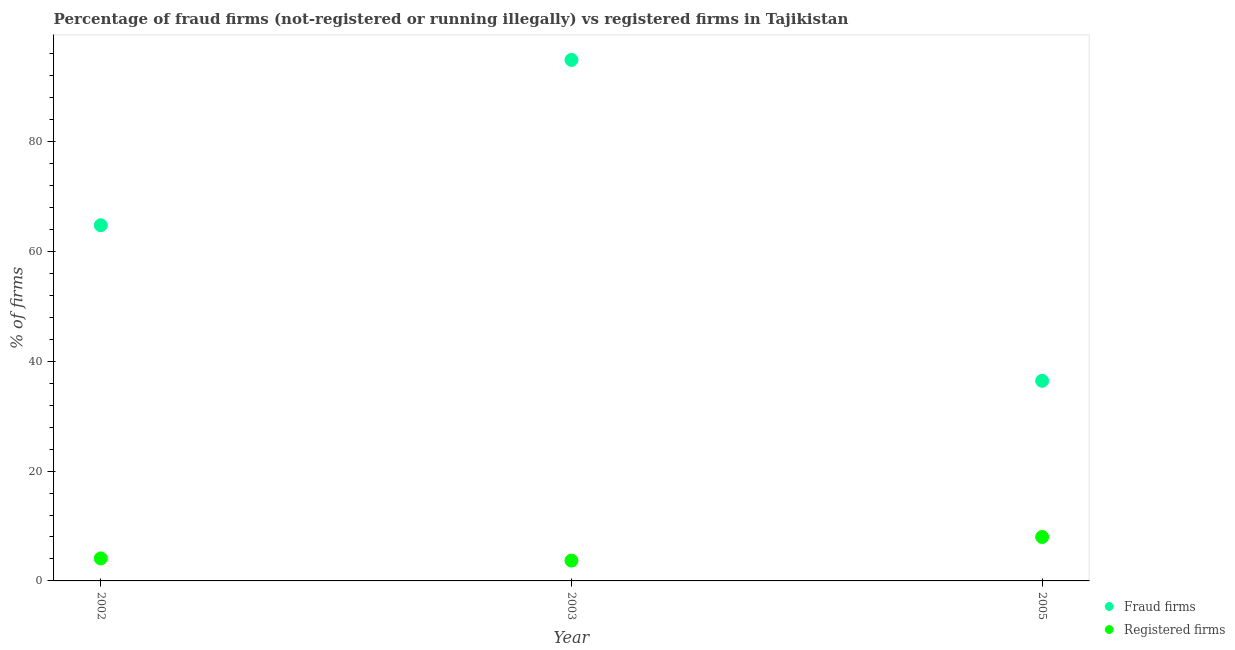How many different coloured dotlines are there?
Your response must be concise. 2. What is the percentage of fraud firms in 2002?
Make the answer very short. 64.75. Across all years, what is the maximum percentage of registered firms?
Make the answer very short. 8. Across all years, what is the minimum percentage of fraud firms?
Provide a short and direct response. 36.43. In which year was the percentage of fraud firms maximum?
Provide a short and direct response. 2003. In which year was the percentage of registered firms minimum?
Offer a very short reply. 2003. What is the total percentage of fraud firms in the graph?
Keep it short and to the point. 196.03. What is the difference between the percentage of registered firms in 2003 and that in 2005?
Ensure brevity in your answer.  -4.3. What is the difference between the percentage of fraud firms in 2003 and the percentage of registered firms in 2002?
Give a very brief answer. 90.75. What is the average percentage of registered firms per year?
Give a very brief answer. 5.27. In the year 2002, what is the difference between the percentage of fraud firms and percentage of registered firms?
Keep it short and to the point. 60.65. What is the ratio of the percentage of fraud firms in 2002 to that in 2003?
Ensure brevity in your answer.  0.68. What is the difference between the highest and the second highest percentage of registered firms?
Keep it short and to the point. 3.9. What is the difference between the highest and the lowest percentage of fraud firms?
Keep it short and to the point. 58.42. In how many years, is the percentage of registered firms greater than the average percentage of registered firms taken over all years?
Give a very brief answer. 1. Is the sum of the percentage of fraud firms in 2002 and 2005 greater than the maximum percentage of registered firms across all years?
Keep it short and to the point. Yes. Is the percentage of fraud firms strictly less than the percentage of registered firms over the years?
Offer a terse response. No. What is the difference between two consecutive major ticks on the Y-axis?
Give a very brief answer. 20. Does the graph contain any zero values?
Your response must be concise. No. Where does the legend appear in the graph?
Provide a succinct answer. Bottom right. How many legend labels are there?
Make the answer very short. 2. What is the title of the graph?
Make the answer very short. Percentage of fraud firms (not-registered or running illegally) vs registered firms in Tajikistan. Does "Rural" appear as one of the legend labels in the graph?
Ensure brevity in your answer.  No. What is the label or title of the X-axis?
Offer a terse response. Year. What is the label or title of the Y-axis?
Make the answer very short. % of firms. What is the % of firms of Fraud firms in 2002?
Offer a terse response. 64.75. What is the % of firms in Fraud firms in 2003?
Ensure brevity in your answer.  94.85. What is the % of firms in Fraud firms in 2005?
Provide a short and direct response. 36.43. What is the % of firms of Registered firms in 2005?
Keep it short and to the point. 8. Across all years, what is the maximum % of firms of Fraud firms?
Keep it short and to the point. 94.85. Across all years, what is the maximum % of firms of Registered firms?
Offer a terse response. 8. Across all years, what is the minimum % of firms of Fraud firms?
Ensure brevity in your answer.  36.43. What is the total % of firms in Fraud firms in the graph?
Your answer should be very brief. 196.03. What is the total % of firms in Registered firms in the graph?
Offer a very short reply. 15.8. What is the difference between the % of firms of Fraud firms in 2002 and that in 2003?
Your response must be concise. -30.1. What is the difference between the % of firms of Fraud firms in 2002 and that in 2005?
Your answer should be compact. 28.32. What is the difference between the % of firms of Registered firms in 2002 and that in 2005?
Keep it short and to the point. -3.9. What is the difference between the % of firms of Fraud firms in 2003 and that in 2005?
Your response must be concise. 58.42. What is the difference between the % of firms of Fraud firms in 2002 and the % of firms of Registered firms in 2003?
Offer a terse response. 61.05. What is the difference between the % of firms of Fraud firms in 2002 and the % of firms of Registered firms in 2005?
Offer a terse response. 56.75. What is the difference between the % of firms in Fraud firms in 2003 and the % of firms in Registered firms in 2005?
Offer a terse response. 86.85. What is the average % of firms of Fraud firms per year?
Make the answer very short. 65.34. What is the average % of firms in Registered firms per year?
Your answer should be very brief. 5.27. In the year 2002, what is the difference between the % of firms of Fraud firms and % of firms of Registered firms?
Provide a succinct answer. 60.65. In the year 2003, what is the difference between the % of firms of Fraud firms and % of firms of Registered firms?
Your response must be concise. 91.15. In the year 2005, what is the difference between the % of firms of Fraud firms and % of firms of Registered firms?
Offer a very short reply. 28.43. What is the ratio of the % of firms of Fraud firms in 2002 to that in 2003?
Make the answer very short. 0.68. What is the ratio of the % of firms in Registered firms in 2002 to that in 2003?
Your response must be concise. 1.11. What is the ratio of the % of firms of Fraud firms in 2002 to that in 2005?
Give a very brief answer. 1.78. What is the ratio of the % of firms in Registered firms in 2002 to that in 2005?
Your response must be concise. 0.51. What is the ratio of the % of firms of Fraud firms in 2003 to that in 2005?
Give a very brief answer. 2.6. What is the ratio of the % of firms of Registered firms in 2003 to that in 2005?
Your response must be concise. 0.46. What is the difference between the highest and the second highest % of firms in Fraud firms?
Offer a very short reply. 30.1. What is the difference between the highest and the second highest % of firms of Registered firms?
Provide a succinct answer. 3.9. What is the difference between the highest and the lowest % of firms in Fraud firms?
Ensure brevity in your answer.  58.42. What is the difference between the highest and the lowest % of firms in Registered firms?
Your answer should be compact. 4.3. 